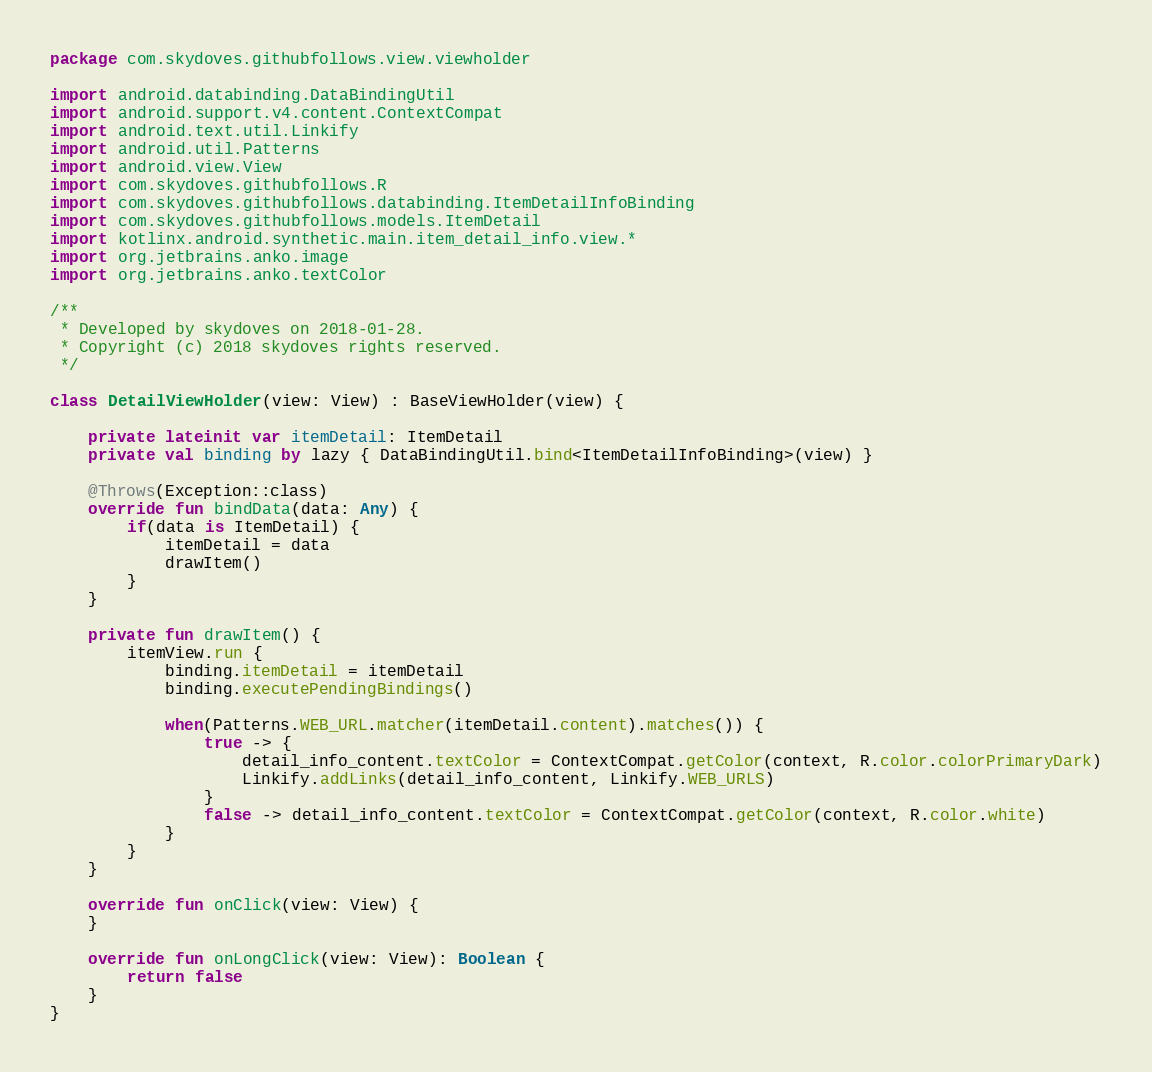<code> <loc_0><loc_0><loc_500><loc_500><_Kotlin_>package com.skydoves.githubfollows.view.viewholder

import android.databinding.DataBindingUtil
import android.support.v4.content.ContextCompat
import android.text.util.Linkify
import android.util.Patterns
import android.view.View
import com.skydoves.githubfollows.R
import com.skydoves.githubfollows.databinding.ItemDetailInfoBinding
import com.skydoves.githubfollows.models.ItemDetail
import kotlinx.android.synthetic.main.item_detail_info.view.*
import org.jetbrains.anko.image
import org.jetbrains.anko.textColor

/**
 * Developed by skydoves on 2018-01-28.
 * Copyright (c) 2018 skydoves rights reserved.
 */

class DetailViewHolder(view: View) : BaseViewHolder(view) {

    private lateinit var itemDetail: ItemDetail
    private val binding by lazy { DataBindingUtil.bind<ItemDetailInfoBinding>(view) }

    @Throws(Exception::class)
    override fun bindData(data: Any) {
        if(data is ItemDetail) {
            itemDetail = data
            drawItem()
        }
    }

    private fun drawItem() {
        itemView.run {
            binding.itemDetail = itemDetail
            binding.executePendingBindings()

            when(Patterns.WEB_URL.matcher(itemDetail.content).matches()) {
                true -> {
                    detail_info_content.textColor = ContextCompat.getColor(context, R.color.colorPrimaryDark)
                    Linkify.addLinks(detail_info_content, Linkify.WEB_URLS)
                }
                false -> detail_info_content.textColor = ContextCompat.getColor(context, R.color.white)
            }
        }
    }

    override fun onClick(view: View) {
    }

    override fun onLongClick(view: View): Boolean {
        return false
    }
}
</code> 